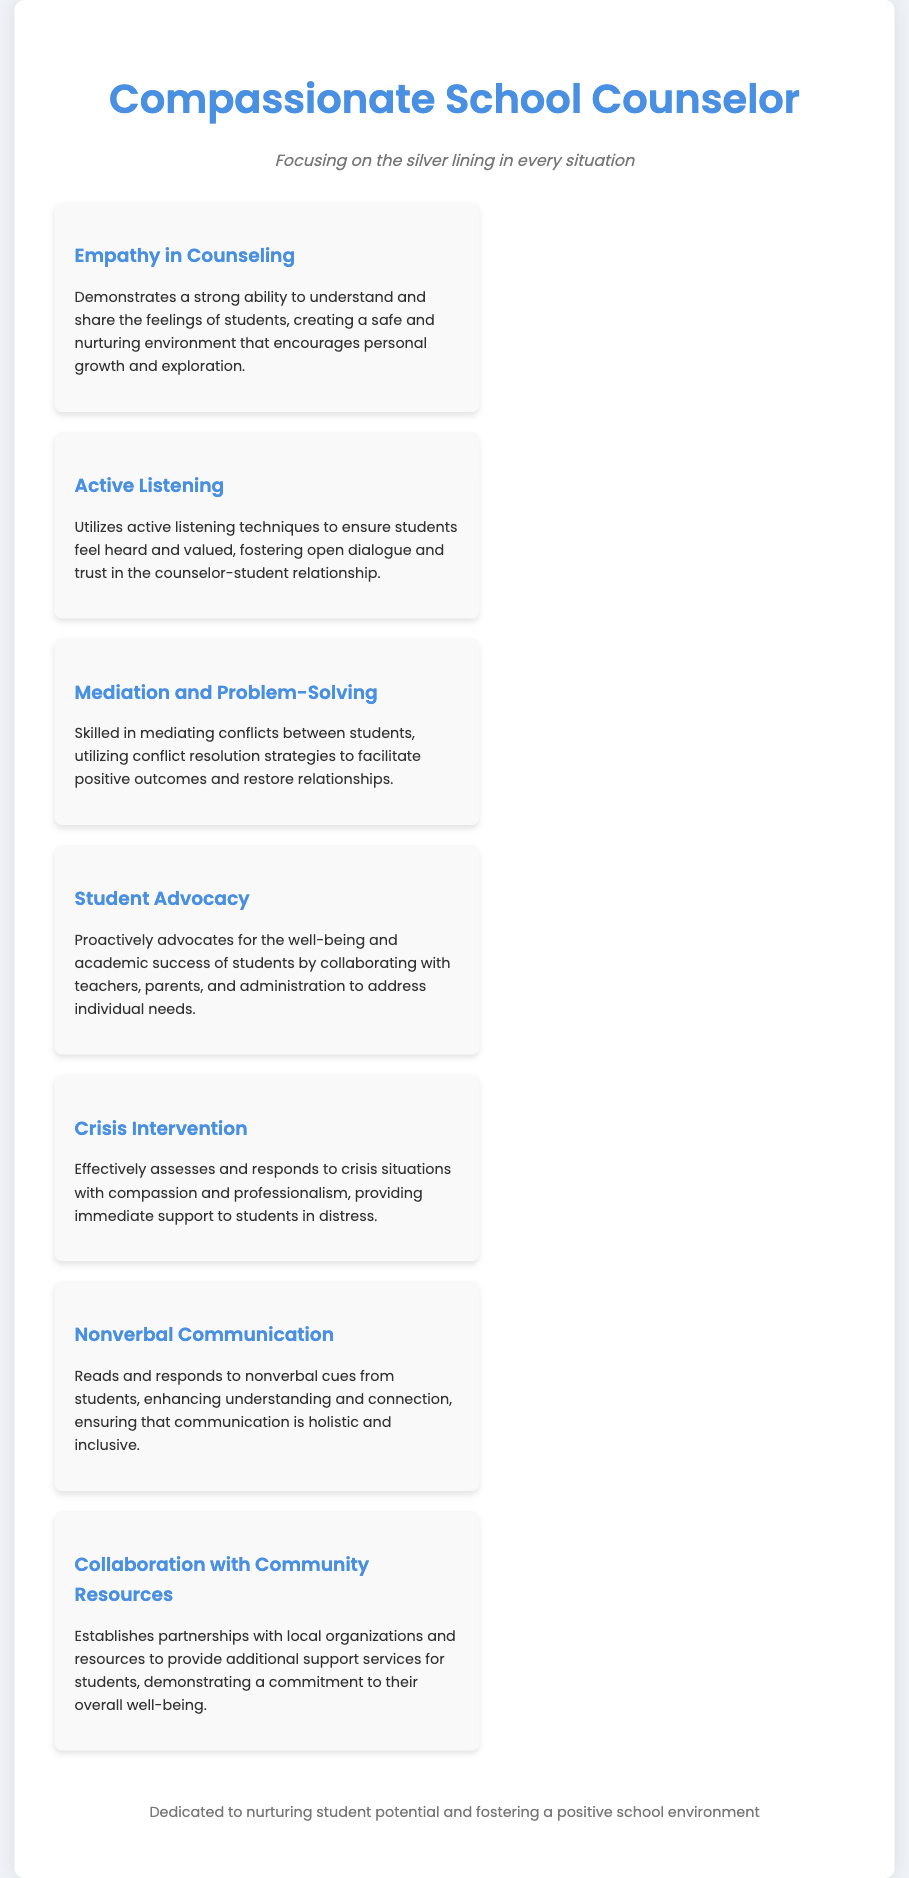What is the title of the document? The title of the document can be found in the header section and refers to the professional identity being portrayed.
Answer: Compassionate School Counselor What skill is associated with understanding and sharing feelings? This skill prominently features in the skills section and emphasizes emotional connection with students.
Answer: Empathy in Counseling How many skills are listed in the skills section? The document details the number of unique skills presented within the skills section.
Answer: Seven Which skill focuses on mediating conflicts? The description associated with this skill details the ability to resolve disputes effectively.
Answer: Mediation and Problem-Solving What is the primary focus of the counseling approach mentioned in the subtitle? The subtitle gives insight into the counselor's overall philosophy and approach towards challenges faced by students.
Answer: Silver lining Which skill entails collaboration with local organizations? This skill specifically refers to building partnerships to support student services.
Answer: Collaboration with Community Resources What is one technique used to ensure students feel heard? This technique highlights an important communication method employed by the counselor to engage with students effectively.
Answer: Active Listening 